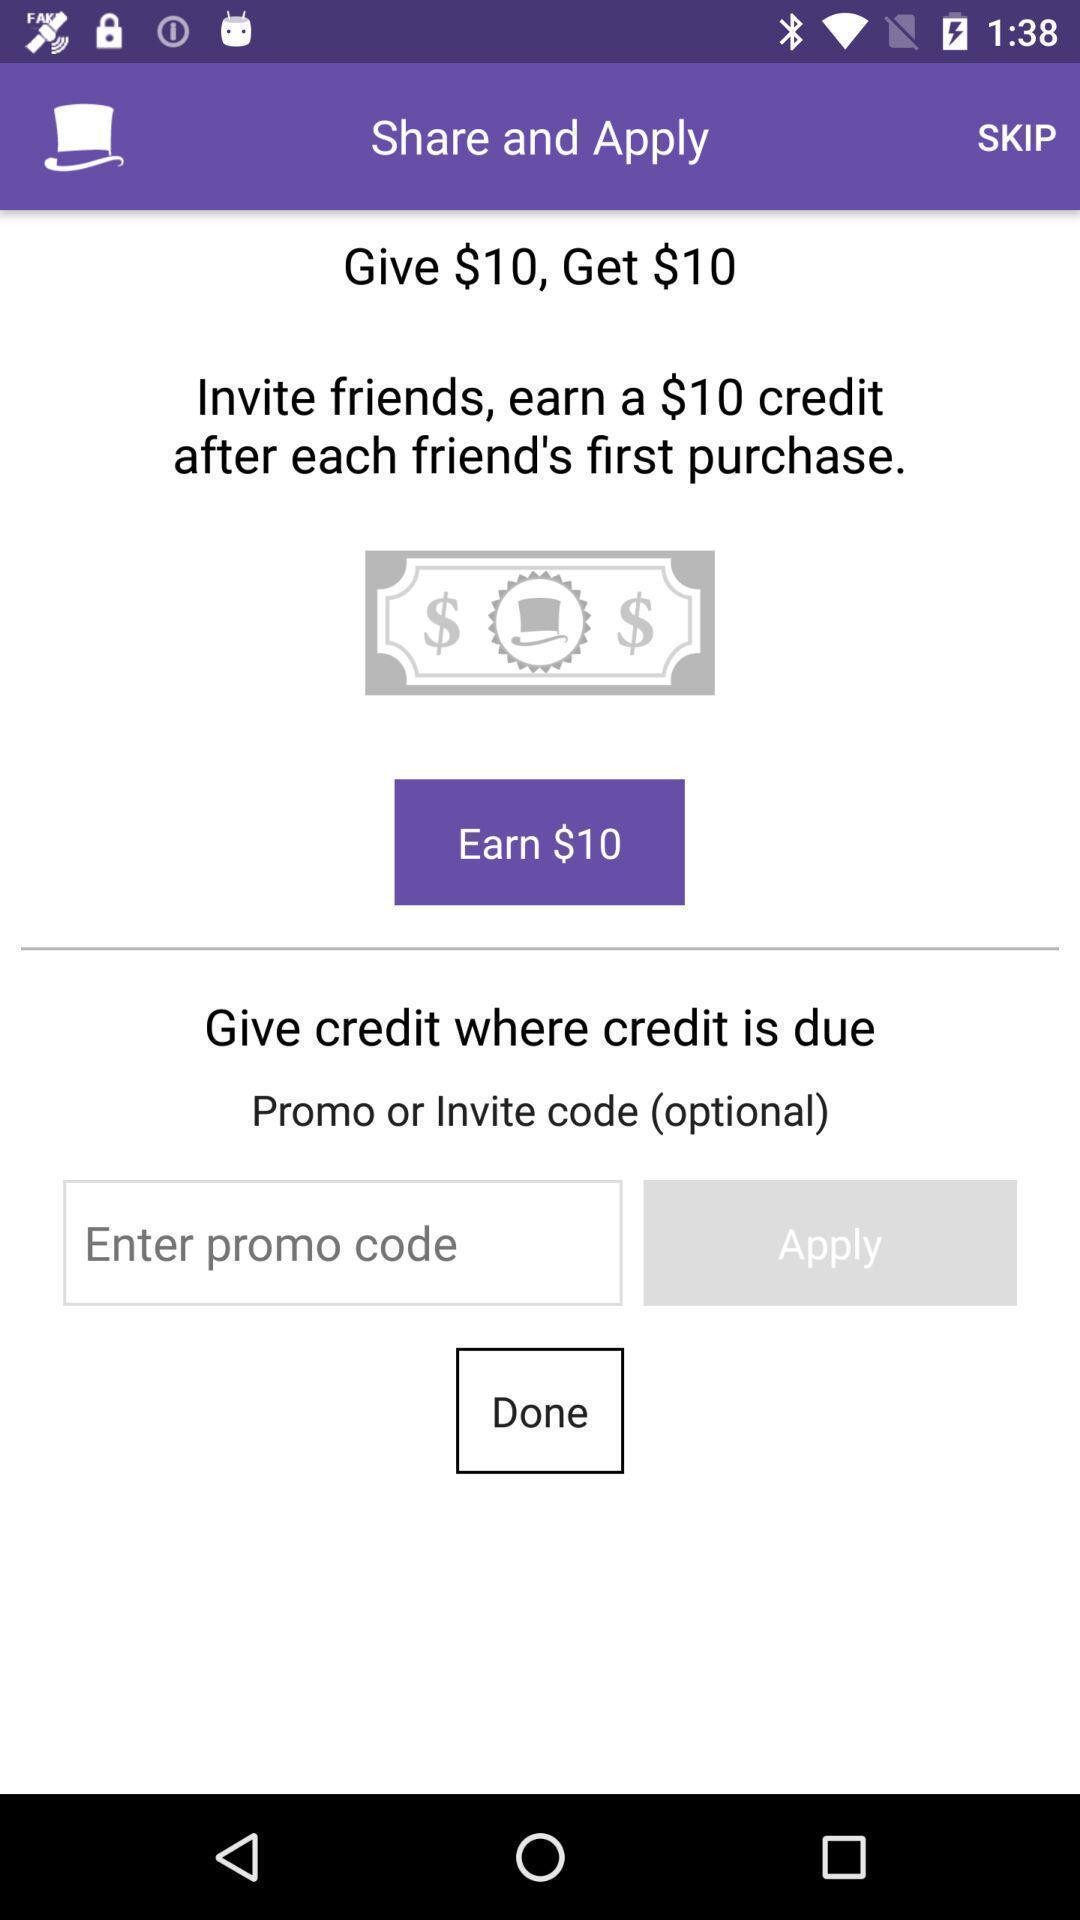What details can you identify in this image? Screen displaying the referral page. 